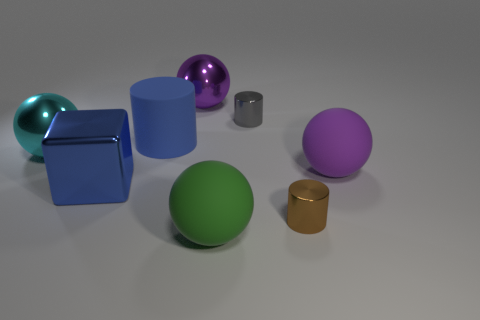Subtract all tiny brown metal cylinders. How many cylinders are left? 2 Subtract all blue cylinders. How many cylinders are left? 2 Add 2 large green objects. How many objects exist? 10 Subtract all cylinders. How many objects are left? 5 Subtract 0 brown balls. How many objects are left? 8 Subtract 3 cylinders. How many cylinders are left? 0 Subtract all red cylinders. Subtract all blue spheres. How many cylinders are left? 3 Subtract all brown balls. How many gray cylinders are left? 1 Subtract all blue shiny blocks. Subtract all gray objects. How many objects are left? 6 Add 7 big purple metallic balls. How many big purple metallic balls are left? 8 